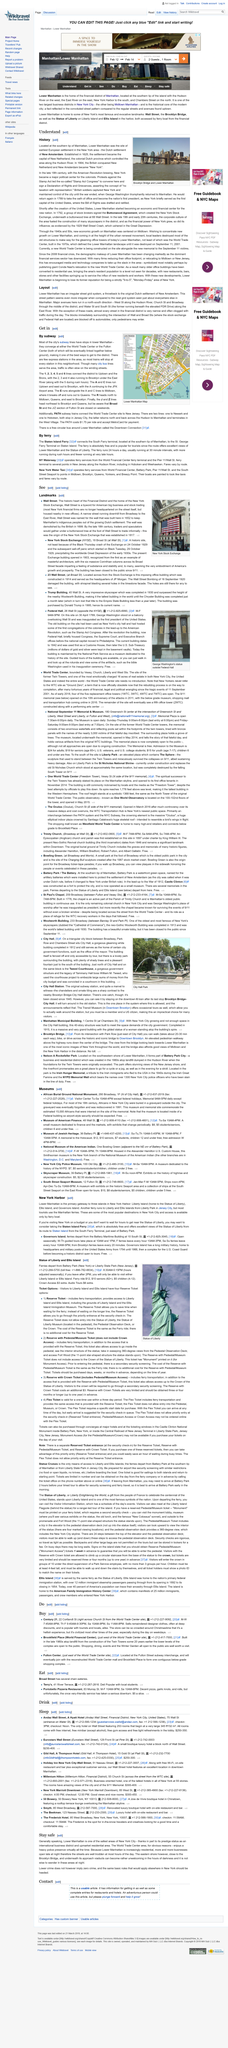Identify some key points in this picture. New York briefly served as the first capital of the United States. The image depicts the Brooklyn Bridge and Lower Manhattan, which are visible in the foreground of the photograph. In history, Lower Manhattan is recognized as the location of the earliest European settlement in the New York Area. 